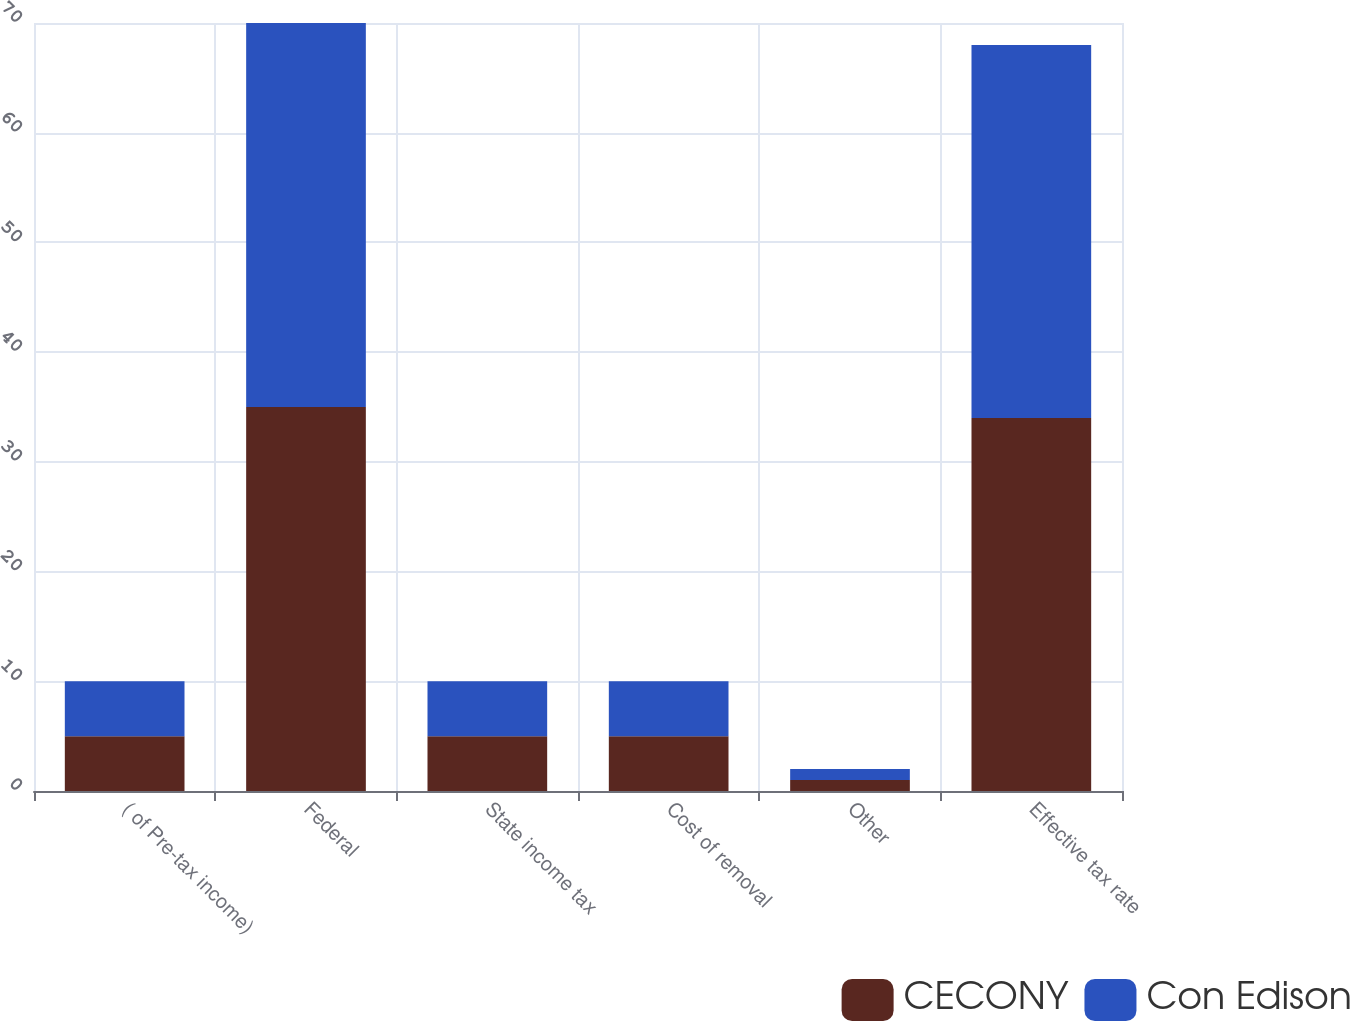Convert chart to OTSL. <chart><loc_0><loc_0><loc_500><loc_500><stacked_bar_chart><ecel><fcel>( of Pre-tax income)<fcel>Federal<fcel>State income tax<fcel>Cost of removal<fcel>Other<fcel>Effective tax rate<nl><fcel>CECONY<fcel>5<fcel>35<fcel>5<fcel>5<fcel>1<fcel>34<nl><fcel>Con Edison<fcel>5<fcel>35<fcel>5<fcel>5<fcel>1<fcel>34<nl></chart> 